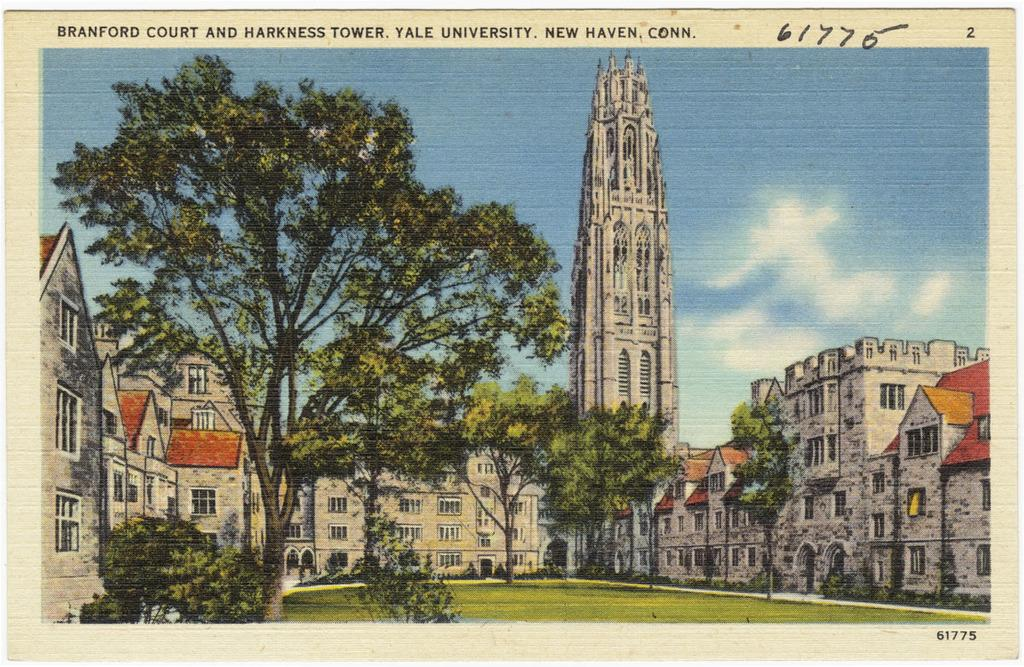What type of structures can be seen in the image? There are buildings in the image. What type of vegetation is present in the image? There are trees in the image. How many women are present in the image? There is no woman present in the image; it only features buildings and trees. What are the boys doing in the image? There are no boys present in the image; it only features buildings and trees. 